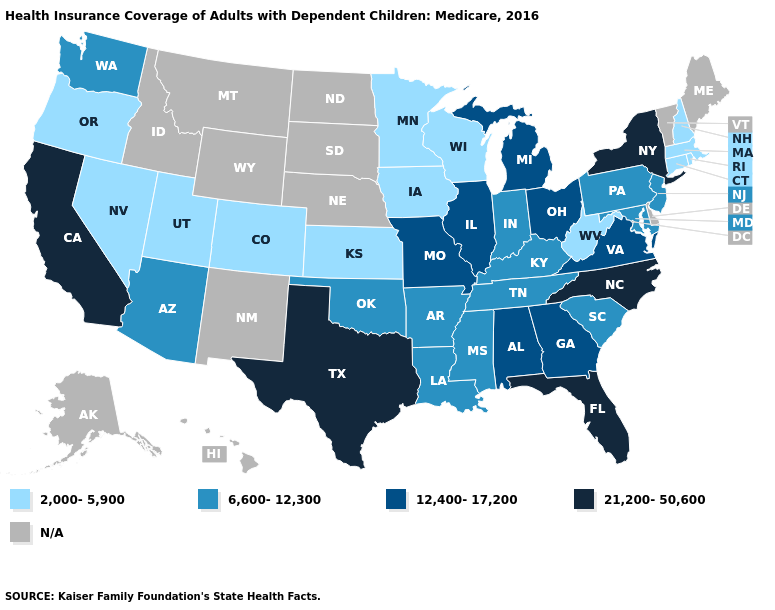Which states have the lowest value in the South?
Be succinct. West Virginia. Which states have the highest value in the USA?
Be succinct. California, Florida, New York, North Carolina, Texas. Among the states that border Wisconsin , which have the lowest value?
Write a very short answer. Iowa, Minnesota. How many symbols are there in the legend?
Short answer required. 5. What is the lowest value in states that border Colorado?
Be succinct. 2,000-5,900. What is the value of Kentucky?
Answer briefly. 6,600-12,300. Which states have the highest value in the USA?
Give a very brief answer. California, Florida, New York, North Carolina, Texas. What is the highest value in the MidWest ?
Quick response, please. 12,400-17,200. What is the lowest value in the USA?
Answer briefly. 2,000-5,900. Name the states that have a value in the range N/A?
Quick response, please. Alaska, Delaware, Hawaii, Idaho, Maine, Montana, Nebraska, New Mexico, North Dakota, South Dakota, Vermont, Wyoming. Name the states that have a value in the range 2,000-5,900?
Give a very brief answer. Colorado, Connecticut, Iowa, Kansas, Massachusetts, Minnesota, Nevada, New Hampshire, Oregon, Rhode Island, Utah, West Virginia, Wisconsin. 